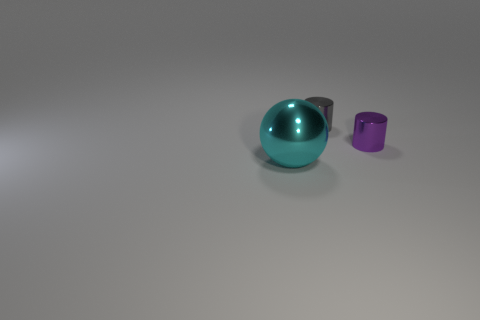Add 1 large metal spheres. How many objects exist? 4 Subtract all cylinders. How many objects are left? 1 Subtract 0 red balls. How many objects are left? 3 Subtract all small gray metal cylinders. Subtract all red metal blocks. How many objects are left? 2 Add 1 gray cylinders. How many gray cylinders are left? 2 Add 2 tiny red matte blocks. How many tiny red matte blocks exist? 2 